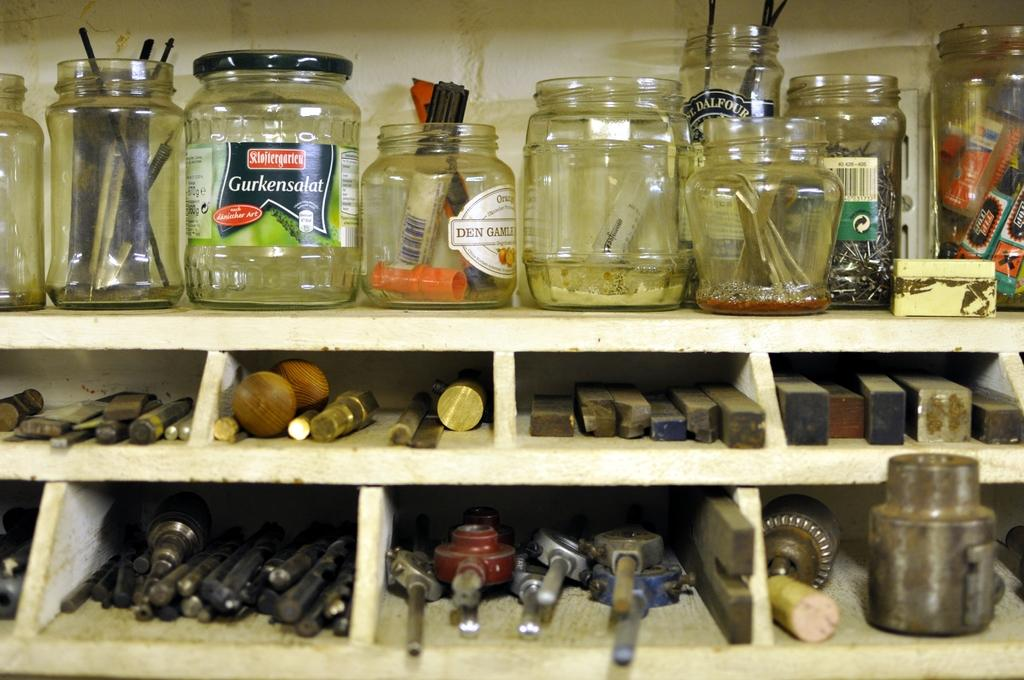What type of objects can be seen in the image? There are jars and tools in the image. Can you describe any specific item in the image? Yes, a marker is visible in the image. What is the background of the image? There is a wall in the image. What historical event is being discussed in the image? There is no historical event being discussed in the image; it only contains jars, tools, a marker, and a wall. 